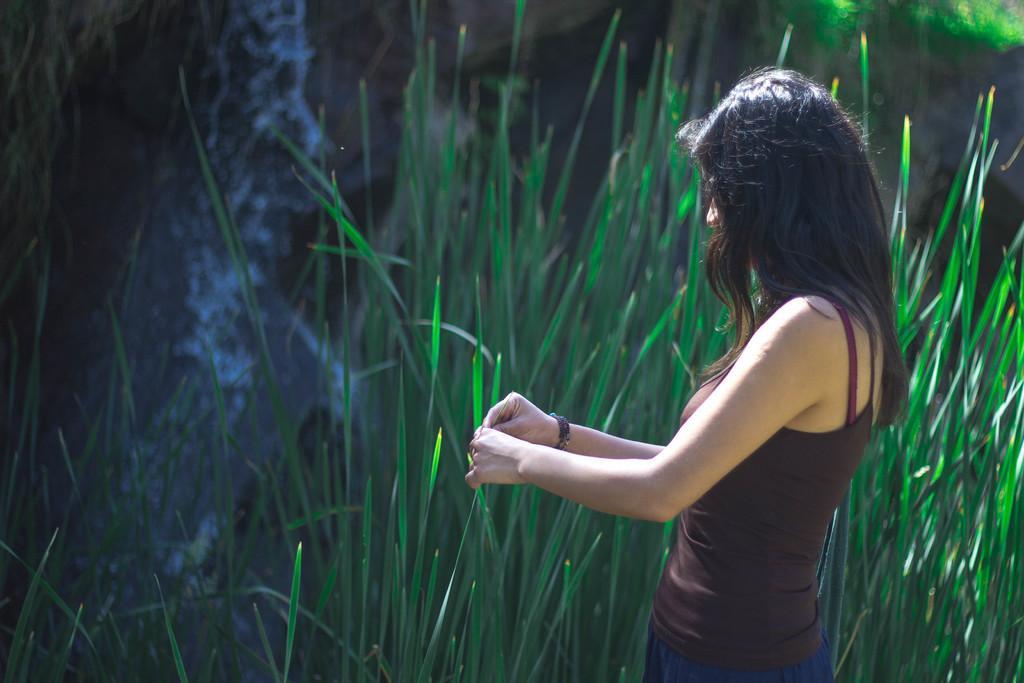Please provide a concise description of this image. On the left side of the image we can see a lady is standing and wearing dress and holding a leaf. In the background of the image we can see the plants, rocks and waterfall. 